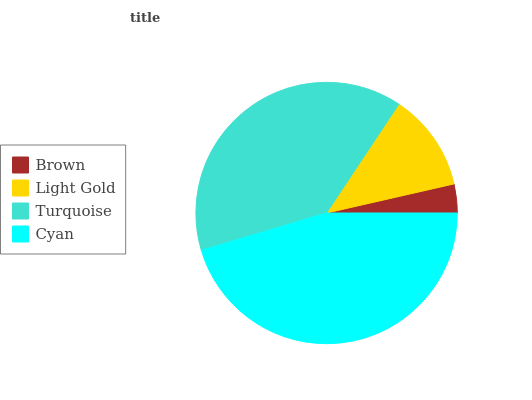Is Brown the minimum?
Answer yes or no. Yes. Is Cyan the maximum?
Answer yes or no. Yes. Is Light Gold the minimum?
Answer yes or no. No. Is Light Gold the maximum?
Answer yes or no. No. Is Light Gold greater than Brown?
Answer yes or no. Yes. Is Brown less than Light Gold?
Answer yes or no. Yes. Is Brown greater than Light Gold?
Answer yes or no. No. Is Light Gold less than Brown?
Answer yes or no. No. Is Turquoise the high median?
Answer yes or no. Yes. Is Light Gold the low median?
Answer yes or no. Yes. Is Brown the high median?
Answer yes or no. No. Is Turquoise the low median?
Answer yes or no. No. 